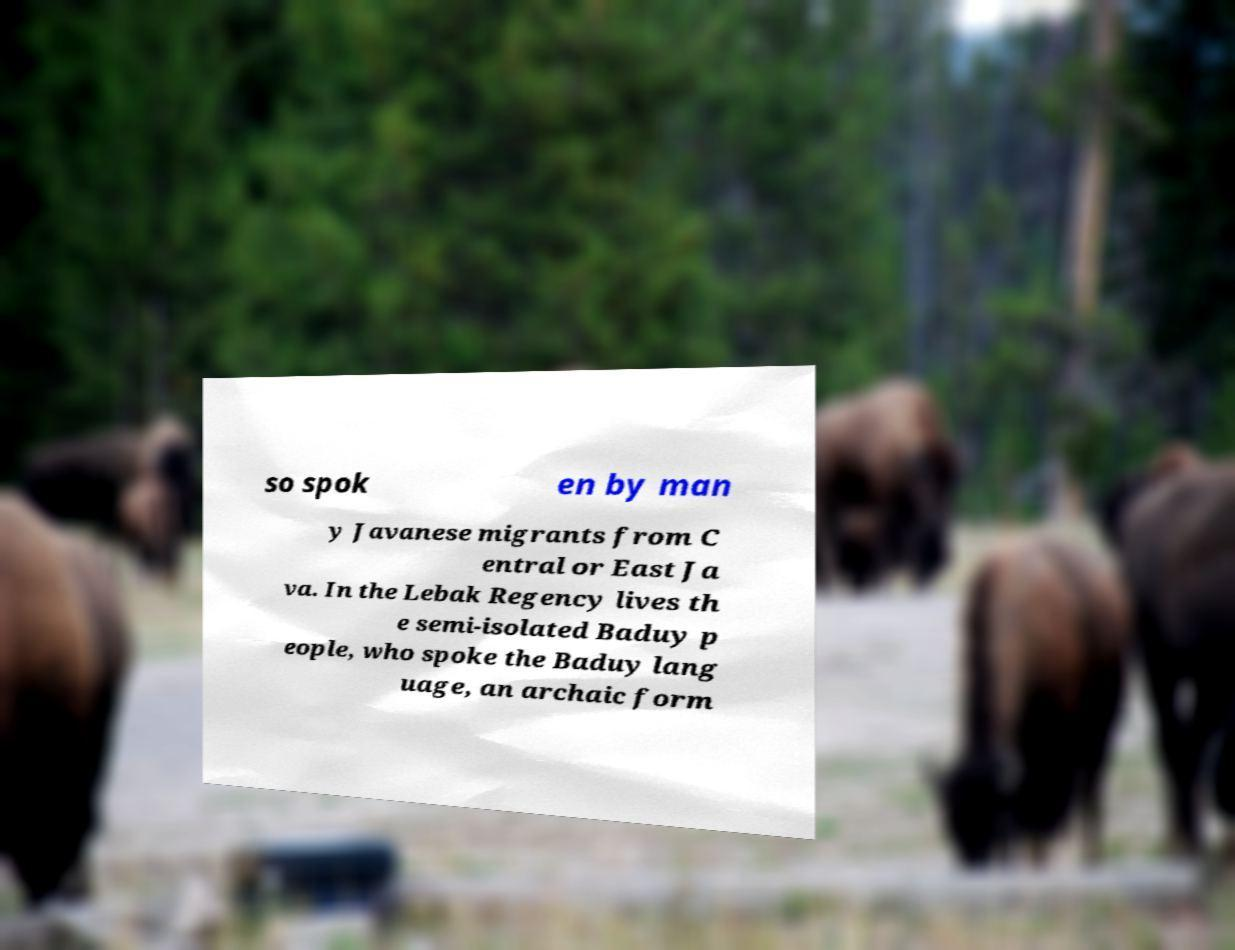For documentation purposes, I need the text within this image transcribed. Could you provide that? so spok en by man y Javanese migrants from C entral or East Ja va. In the Lebak Regency lives th e semi-isolated Baduy p eople, who spoke the Baduy lang uage, an archaic form 